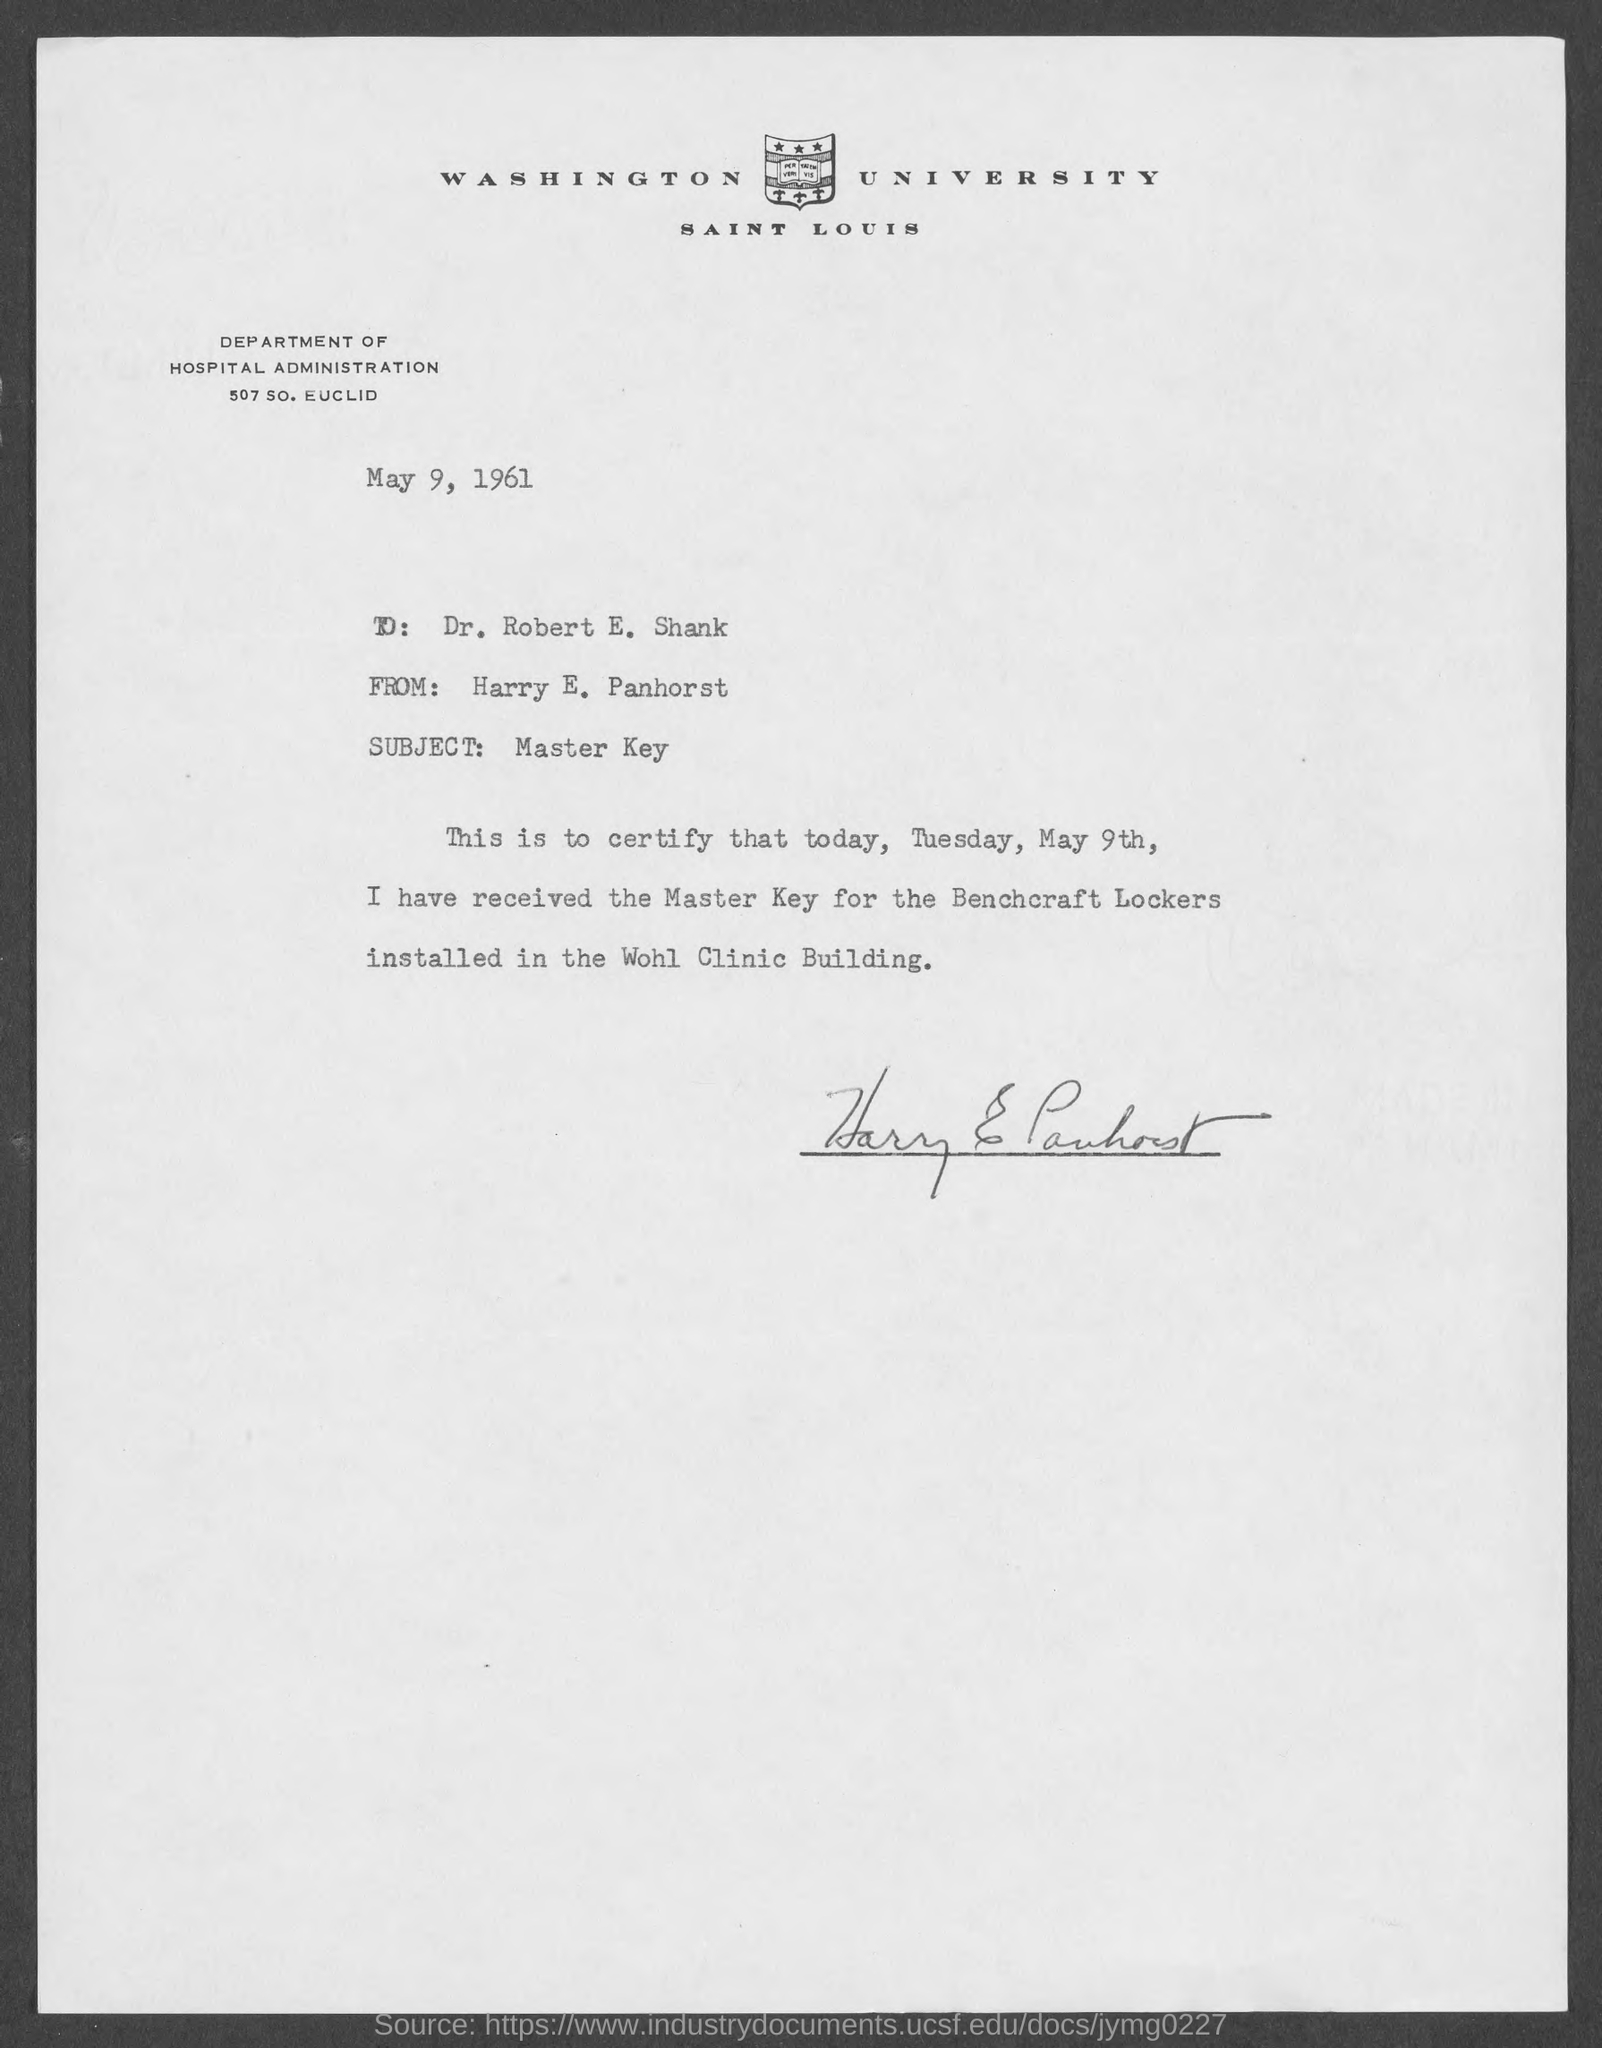Indicate a few pertinent items in this graphic. The master key was received on Tuesday. The subject of the memorandum is the Master Key. The address of the Department of Hospital Administration is located at 507 South Euclid. The memorandum was dated May 9, 1961. The memorandum is addressing "what is from address in memorandum" and the sender is Harry E. Panhorst. 